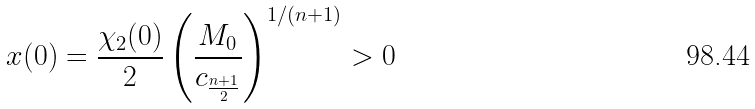<formula> <loc_0><loc_0><loc_500><loc_500>x ( 0 ) = \frac { \chi _ { 2 } ( 0 ) } { 2 } \left ( \frac { M _ { 0 } } { c _ { \frac { n + 1 } { 2 } } } \right ) ^ { 1 / ( n + 1 ) } > 0</formula> 